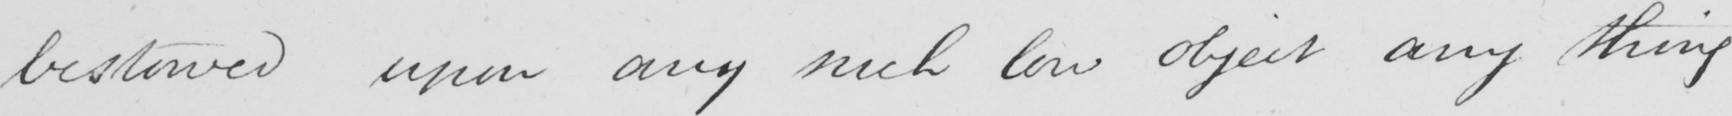Transcribe the text shown in this historical manuscript line. bestowed upon any such low object any thing 